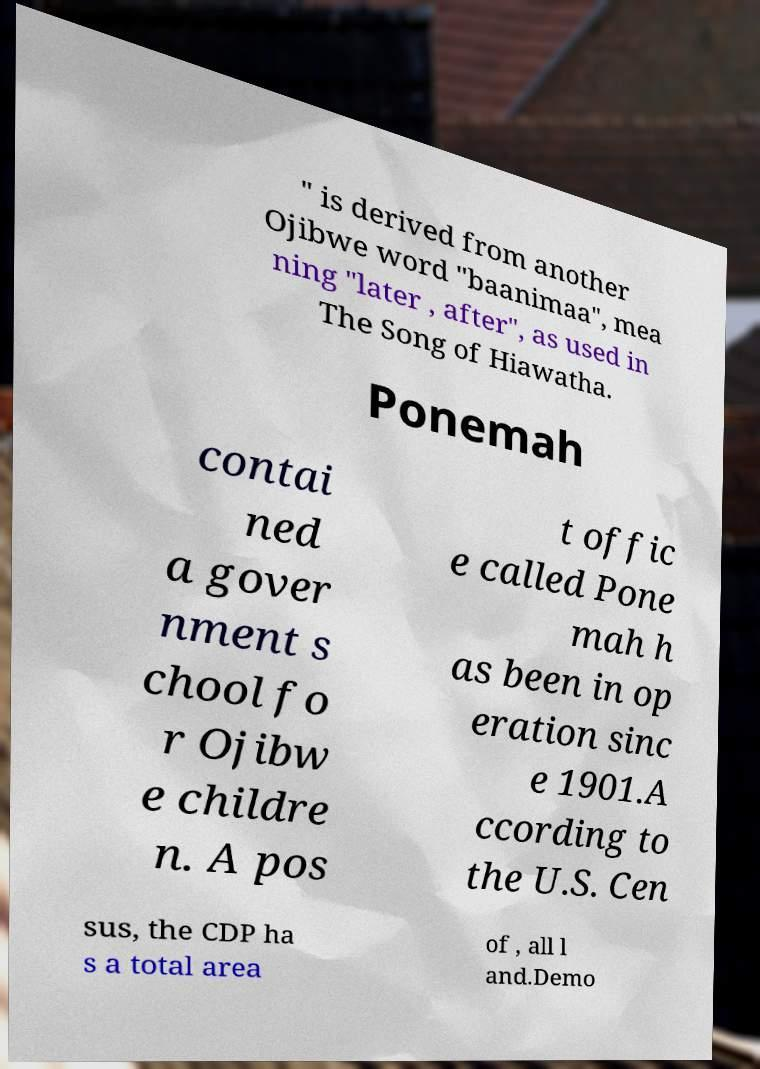There's text embedded in this image that I need extracted. Can you transcribe it verbatim? " is derived from another Ojibwe word "baanimaa", mea ning "later , after", as used in The Song of Hiawatha. Ponemah contai ned a gover nment s chool fo r Ojibw e childre n. A pos t offic e called Pone mah h as been in op eration sinc e 1901.A ccording to the U.S. Cen sus, the CDP ha s a total area of , all l and.Demo 